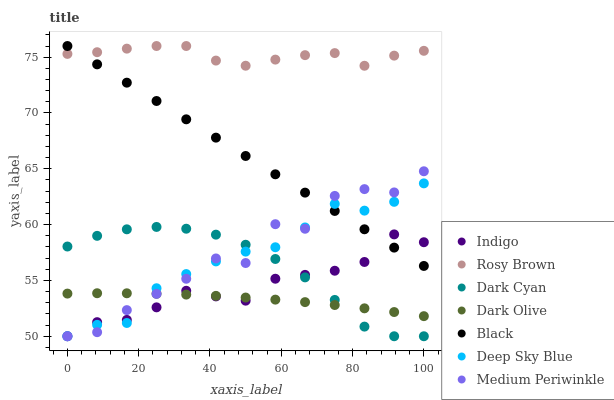Does Dark Olive have the minimum area under the curve?
Answer yes or no. Yes. Does Rosy Brown have the maximum area under the curve?
Answer yes or no. Yes. Does Indigo have the minimum area under the curve?
Answer yes or no. No. Does Indigo have the maximum area under the curve?
Answer yes or no. No. Is Black the smoothest?
Answer yes or no. Yes. Is Medium Periwinkle the roughest?
Answer yes or no. Yes. Is Indigo the smoothest?
Answer yes or no. No. Is Indigo the roughest?
Answer yes or no. No. Does Indigo have the lowest value?
Answer yes or no. Yes. Does Dark Olive have the lowest value?
Answer yes or no. No. Does Black have the highest value?
Answer yes or no. Yes. Does Indigo have the highest value?
Answer yes or no. No. Is Deep Sky Blue less than Rosy Brown?
Answer yes or no. Yes. Is Rosy Brown greater than Dark Olive?
Answer yes or no. Yes. Does Medium Periwinkle intersect Dark Olive?
Answer yes or no. Yes. Is Medium Periwinkle less than Dark Olive?
Answer yes or no. No. Is Medium Periwinkle greater than Dark Olive?
Answer yes or no. No. Does Deep Sky Blue intersect Rosy Brown?
Answer yes or no. No. 